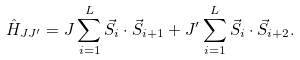Convert formula to latex. <formula><loc_0><loc_0><loc_500><loc_500>\hat { H } _ { J J ^ { \prime } } = J \sum _ { i = 1 } ^ { L } \vec { S } _ { i } \cdot \vec { S } _ { i + 1 } + J ^ { \prime } \sum _ { i = 1 } ^ { L } \vec { S } _ { i } \cdot \vec { S } _ { i + 2 } .</formula> 